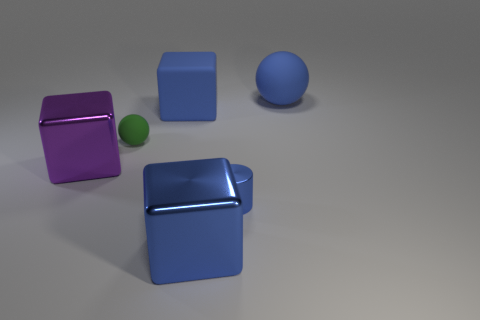What number of objects are yellow things or blue objects?
Keep it short and to the point. 4. Are the big blue block in front of the big purple metallic thing and the blue cube behind the large purple shiny thing made of the same material?
Make the answer very short. No. The other block that is the same material as the large purple block is what color?
Keep it short and to the point. Blue. How many metal objects are the same size as the green sphere?
Your answer should be very brief. 1. How many other things are there of the same color as the large rubber cube?
Give a very brief answer. 3. There is a blue matte object in front of the blue matte sphere; does it have the same shape as the large shiny thing in front of the purple metal block?
Keep it short and to the point. Yes. What shape is the blue metallic object that is the same size as the purple metal object?
Ensure brevity in your answer.  Cube. Is the number of big shiny blocks on the right side of the small rubber sphere the same as the number of small blue objects in front of the big matte sphere?
Offer a terse response. Yes. Is there any other thing that has the same shape as the tiny blue thing?
Provide a short and direct response. No. Is the material of the blue object on the right side of the small blue metallic object the same as the tiny green object?
Your answer should be very brief. Yes. 